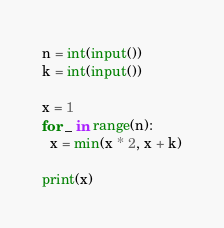<code> <loc_0><loc_0><loc_500><loc_500><_Python_>n = int(input())
k = int(input())

x = 1
for _ in range(n):
  x = min(x * 2, x + k)

print(x)</code> 